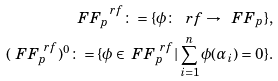Convert formula to latex. <formula><loc_0><loc_0><loc_500><loc_500>\ F F _ { p } ^ { \ r f } \colon = \{ \phi \colon \ r f \rightarrow \ F F _ { p } \} , \\ ( \ F F _ { p } ^ { \ r f } ) ^ { 0 } \colon = \{ \phi \in \ F F _ { p } ^ { \ r f } | \sum _ { i = 1 } ^ { n } \phi ( \alpha _ { i } ) = 0 \} .</formula> 